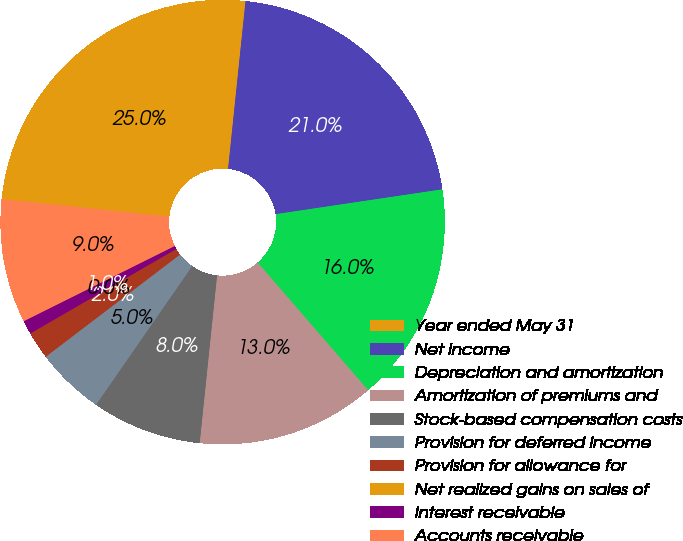Convert chart to OTSL. <chart><loc_0><loc_0><loc_500><loc_500><pie_chart><fcel>Year ended May 31<fcel>Net income<fcel>Depreciation and amortization<fcel>Amortization of premiums and<fcel>Stock-based compensation costs<fcel>Provision for deferred income<fcel>Provision for allowance for<fcel>Net realized gains on sales of<fcel>Interest receivable<fcel>Accounts receivable<nl><fcel>25.0%<fcel>21.0%<fcel>16.0%<fcel>13.0%<fcel>8.0%<fcel>5.0%<fcel>2.0%<fcel>0.0%<fcel>1.0%<fcel>9.0%<nl></chart> 